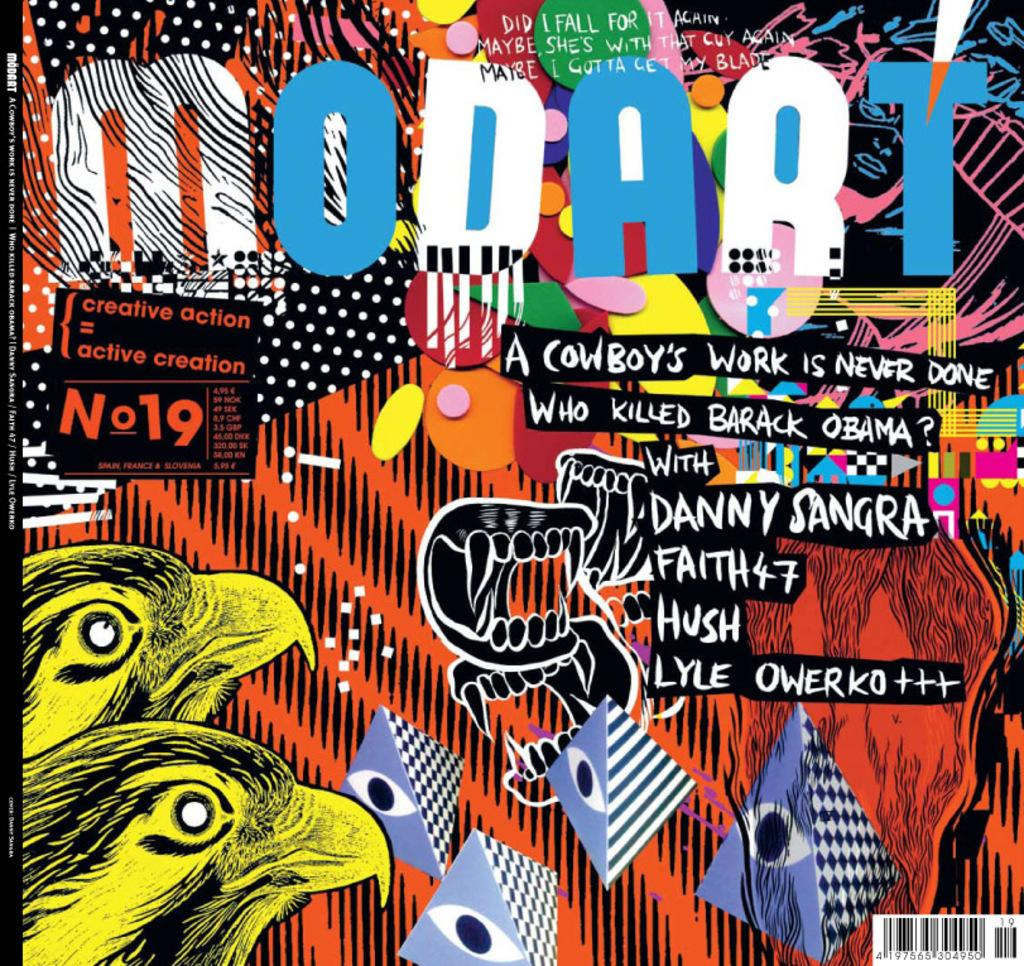What is present on the poster in the image? The image contains a poster with text and animations. What types of animations are on the poster? The poster has animations of birds, a snake, and kites. Can you describe the text on the poster? Unfortunately, the text on the poster cannot be described without more information about its content. What type of alarm can be heard going off in the image? There is no alarm present in the image; it only contains a poster with animations and text. 